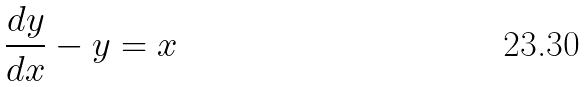Convert formula to latex. <formula><loc_0><loc_0><loc_500><loc_500>\frac { d y } { d x } - y = x</formula> 